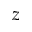Convert formula to latex. <formula><loc_0><loc_0><loc_500><loc_500>z</formula> 